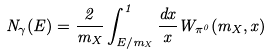Convert formula to latex. <formula><loc_0><loc_0><loc_500><loc_500>N _ { \gamma } ( E ) = \frac { 2 } { m _ { X } } \int _ { E / m _ { X } } ^ { 1 } \frac { d x } { x } W _ { \pi ^ { 0 } } ( m _ { X } , x )</formula> 